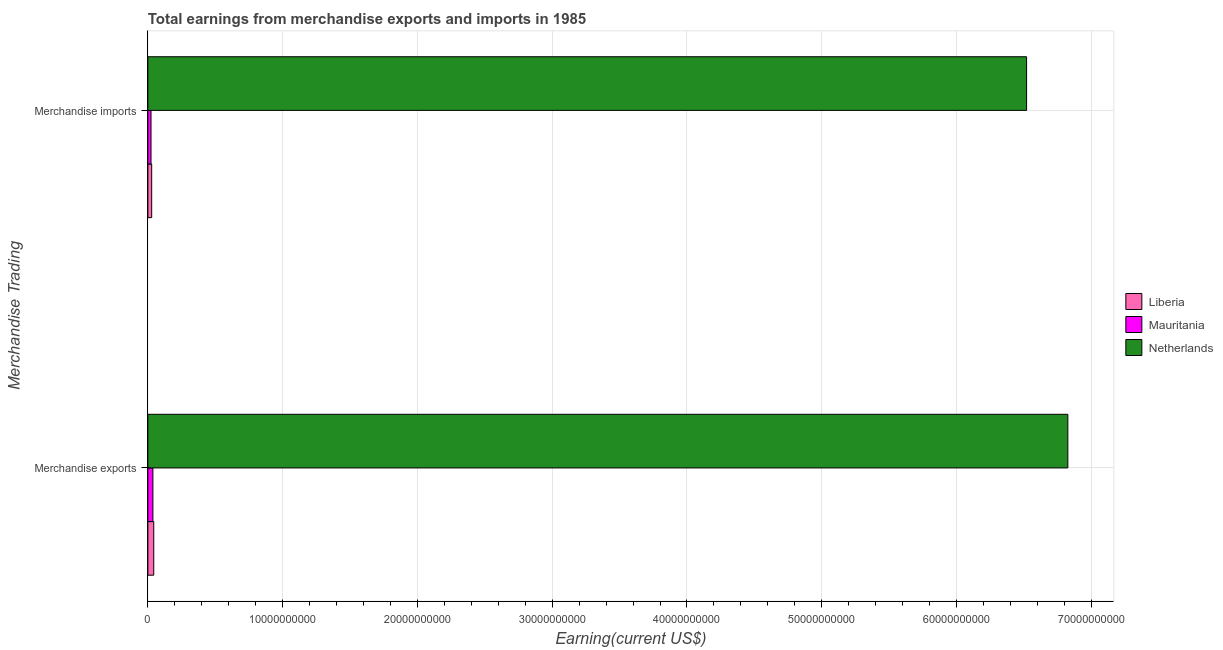How many bars are there on the 1st tick from the bottom?
Provide a succinct answer. 3. What is the label of the 1st group of bars from the top?
Offer a very short reply. Merchandise imports. What is the earnings from merchandise exports in Mauritania?
Provide a short and direct response. 3.74e+08. Across all countries, what is the maximum earnings from merchandise exports?
Provide a short and direct response. 6.83e+1. Across all countries, what is the minimum earnings from merchandise exports?
Your answer should be compact. 3.74e+08. In which country was the earnings from merchandise imports minimum?
Give a very brief answer. Mauritania. What is the total earnings from merchandise exports in the graph?
Keep it short and to the point. 6.91e+1. What is the difference between the earnings from merchandise exports in Liberia and that in Mauritania?
Ensure brevity in your answer.  6.20e+07. What is the difference between the earnings from merchandise exports in Mauritania and the earnings from merchandise imports in Netherlands?
Offer a very short reply. -6.48e+1. What is the average earnings from merchandise exports per country?
Keep it short and to the point. 2.30e+1. What is the difference between the earnings from merchandise exports and earnings from merchandise imports in Netherlands?
Provide a succinct answer. 3.06e+09. What is the ratio of the earnings from merchandise imports in Mauritania to that in Netherlands?
Give a very brief answer. 0. In how many countries, is the earnings from merchandise exports greater than the average earnings from merchandise exports taken over all countries?
Provide a short and direct response. 1. What does the 2nd bar from the top in Merchandise exports represents?
Keep it short and to the point. Mauritania. What does the 2nd bar from the bottom in Merchandise exports represents?
Offer a very short reply. Mauritania. How many countries are there in the graph?
Your answer should be very brief. 3. What is the difference between two consecutive major ticks on the X-axis?
Offer a terse response. 1.00e+1. Are the values on the major ticks of X-axis written in scientific E-notation?
Ensure brevity in your answer.  No. How many legend labels are there?
Provide a succinct answer. 3. What is the title of the graph?
Your response must be concise. Total earnings from merchandise exports and imports in 1985. Does "Swaziland" appear as one of the legend labels in the graph?
Keep it short and to the point. No. What is the label or title of the X-axis?
Offer a terse response. Earning(current US$). What is the label or title of the Y-axis?
Provide a short and direct response. Merchandise Trading. What is the Earning(current US$) in Liberia in Merchandise exports?
Keep it short and to the point. 4.36e+08. What is the Earning(current US$) in Mauritania in Merchandise exports?
Keep it short and to the point. 3.74e+08. What is the Earning(current US$) of Netherlands in Merchandise exports?
Give a very brief answer. 6.83e+1. What is the Earning(current US$) of Liberia in Merchandise imports?
Provide a short and direct response. 2.84e+08. What is the Earning(current US$) in Mauritania in Merchandise imports?
Provide a succinct answer. 2.34e+08. What is the Earning(current US$) in Netherlands in Merchandise imports?
Make the answer very short. 6.52e+1. Across all Merchandise Trading, what is the maximum Earning(current US$) in Liberia?
Offer a very short reply. 4.36e+08. Across all Merchandise Trading, what is the maximum Earning(current US$) in Mauritania?
Offer a very short reply. 3.74e+08. Across all Merchandise Trading, what is the maximum Earning(current US$) in Netherlands?
Ensure brevity in your answer.  6.83e+1. Across all Merchandise Trading, what is the minimum Earning(current US$) in Liberia?
Provide a short and direct response. 2.84e+08. Across all Merchandise Trading, what is the minimum Earning(current US$) of Mauritania?
Offer a terse response. 2.34e+08. Across all Merchandise Trading, what is the minimum Earning(current US$) in Netherlands?
Keep it short and to the point. 6.52e+1. What is the total Earning(current US$) in Liberia in the graph?
Keep it short and to the point. 7.20e+08. What is the total Earning(current US$) of Mauritania in the graph?
Your response must be concise. 6.08e+08. What is the total Earning(current US$) of Netherlands in the graph?
Your answer should be compact. 1.33e+11. What is the difference between the Earning(current US$) of Liberia in Merchandise exports and that in Merchandise imports?
Your response must be concise. 1.52e+08. What is the difference between the Earning(current US$) in Mauritania in Merchandise exports and that in Merchandise imports?
Provide a succinct answer. 1.40e+08. What is the difference between the Earning(current US$) of Netherlands in Merchandise exports and that in Merchandise imports?
Ensure brevity in your answer.  3.06e+09. What is the difference between the Earning(current US$) of Liberia in Merchandise exports and the Earning(current US$) of Mauritania in Merchandise imports?
Keep it short and to the point. 2.02e+08. What is the difference between the Earning(current US$) in Liberia in Merchandise exports and the Earning(current US$) in Netherlands in Merchandise imports?
Your answer should be compact. -6.48e+1. What is the difference between the Earning(current US$) in Mauritania in Merchandise exports and the Earning(current US$) in Netherlands in Merchandise imports?
Make the answer very short. -6.48e+1. What is the average Earning(current US$) of Liberia per Merchandise Trading?
Give a very brief answer. 3.60e+08. What is the average Earning(current US$) in Mauritania per Merchandise Trading?
Your answer should be very brief. 3.04e+08. What is the average Earning(current US$) of Netherlands per Merchandise Trading?
Provide a short and direct response. 6.67e+1. What is the difference between the Earning(current US$) of Liberia and Earning(current US$) of Mauritania in Merchandise exports?
Your answer should be compact. 6.20e+07. What is the difference between the Earning(current US$) in Liberia and Earning(current US$) in Netherlands in Merchandise exports?
Make the answer very short. -6.78e+1. What is the difference between the Earning(current US$) in Mauritania and Earning(current US$) in Netherlands in Merchandise exports?
Give a very brief answer. -6.79e+1. What is the difference between the Earning(current US$) in Liberia and Earning(current US$) in Mauritania in Merchandise imports?
Provide a short and direct response. 5.00e+07. What is the difference between the Earning(current US$) of Liberia and Earning(current US$) of Netherlands in Merchandise imports?
Offer a terse response. -6.49e+1. What is the difference between the Earning(current US$) of Mauritania and Earning(current US$) of Netherlands in Merchandise imports?
Your answer should be compact. -6.50e+1. What is the ratio of the Earning(current US$) in Liberia in Merchandise exports to that in Merchandise imports?
Offer a terse response. 1.54. What is the ratio of the Earning(current US$) in Mauritania in Merchandise exports to that in Merchandise imports?
Ensure brevity in your answer.  1.6. What is the ratio of the Earning(current US$) of Netherlands in Merchandise exports to that in Merchandise imports?
Give a very brief answer. 1.05. What is the difference between the highest and the second highest Earning(current US$) of Liberia?
Make the answer very short. 1.52e+08. What is the difference between the highest and the second highest Earning(current US$) in Mauritania?
Provide a succinct answer. 1.40e+08. What is the difference between the highest and the second highest Earning(current US$) in Netherlands?
Ensure brevity in your answer.  3.06e+09. What is the difference between the highest and the lowest Earning(current US$) in Liberia?
Your answer should be compact. 1.52e+08. What is the difference between the highest and the lowest Earning(current US$) of Mauritania?
Provide a succinct answer. 1.40e+08. What is the difference between the highest and the lowest Earning(current US$) of Netherlands?
Make the answer very short. 3.06e+09. 